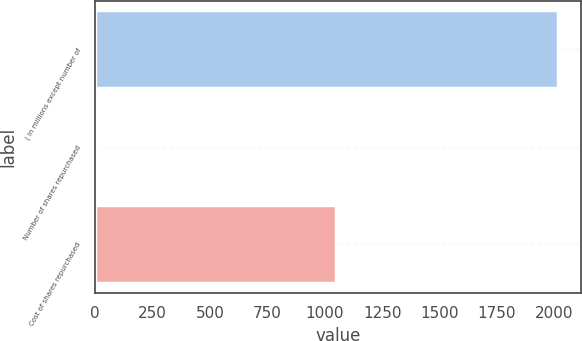Convert chart. <chart><loc_0><loc_0><loc_500><loc_500><bar_chart><fcel>( in millions except number of<fcel>Number of shares repurchased<fcel>Cost of shares repurchased<nl><fcel>2016<fcel>10.7<fcel>1050<nl></chart> 